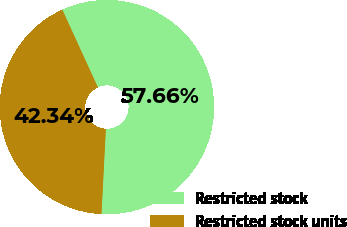Convert chart to OTSL. <chart><loc_0><loc_0><loc_500><loc_500><pie_chart><fcel>Restricted stock<fcel>Restricted stock units<nl><fcel>57.66%<fcel>42.34%<nl></chart> 